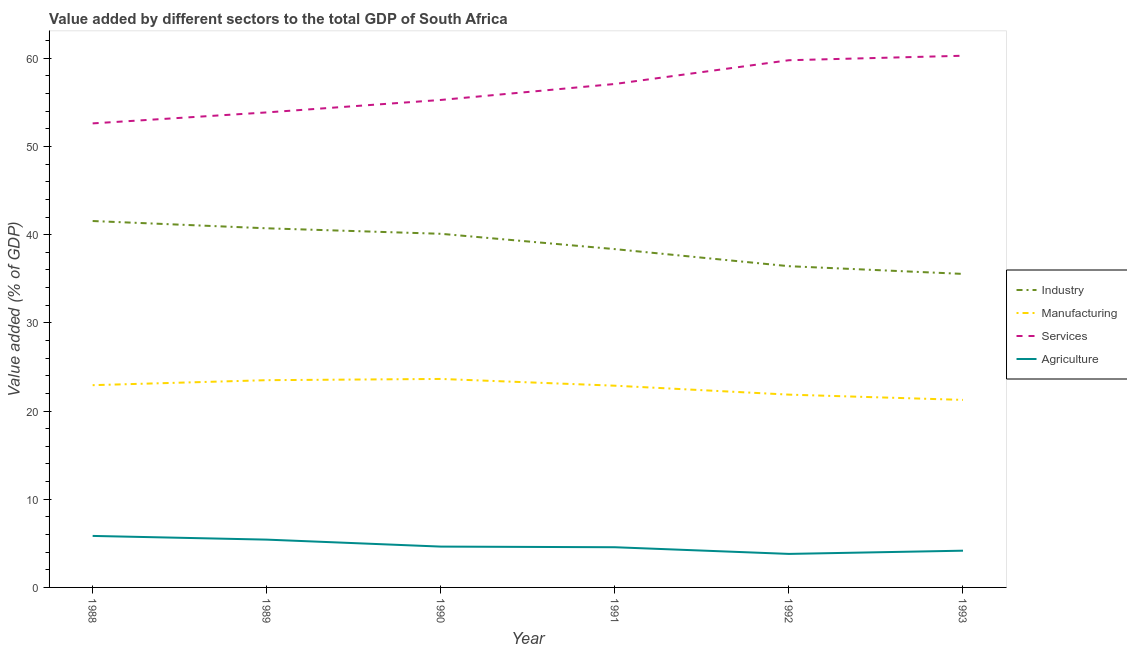Does the line corresponding to value added by industrial sector intersect with the line corresponding to value added by manufacturing sector?
Provide a succinct answer. No. Is the number of lines equal to the number of legend labels?
Give a very brief answer. Yes. What is the value added by services sector in 1990?
Provide a short and direct response. 55.27. Across all years, what is the maximum value added by manufacturing sector?
Keep it short and to the point. 23.64. Across all years, what is the minimum value added by industrial sector?
Offer a terse response. 35.55. What is the total value added by agricultural sector in the graph?
Provide a short and direct response. 28.41. What is the difference between the value added by industrial sector in 1988 and that in 1991?
Keep it short and to the point. 3.19. What is the difference between the value added by manufacturing sector in 1993 and the value added by services sector in 1991?
Your answer should be compact. -35.82. What is the average value added by services sector per year?
Offer a very short reply. 56.48. In the year 1990, what is the difference between the value added by agricultural sector and value added by services sector?
Offer a terse response. -50.64. What is the ratio of the value added by industrial sector in 1992 to that in 1993?
Provide a succinct answer. 1.02. Is the difference between the value added by services sector in 1990 and 1992 greater than the difference between the value added by agricultural sector in 1990 and 1992?
Your response must be concise. No. What is the difference between the highest and the second highest value added by industrial sector?
Keep it short and to the point. 0.83. What is the difference between the highest and the lowest value added by industrial sector?
Offer a very short reply. 6. Is the sum of the value added by agricultural sector in 1989 and 1993 greater than the maximum value added by services sector across all years?
Give a very brief answer. No. Is it the case that in every year, the sum of the value added by agricultural sector and value added by industrial sector is greater than the sum of value added by manufacturing sector and value added by services sector?
Provide a succinct answer. Yes. How many years are there in the graph?
Ensure brevity in your answer.  6. Are the values on the major ticks of Y-axis written in scientific E-notation?
Make the answer very short. No. Does the graph contain any zero values?
Keep it short and to the point. No. Where does the legend appear in the graph?
Ensure brevity in your answer.  Center right. How are the legend labels stacked?
Provide a succinct answer. Vertical. What is the title of the graph?
Give a very brief answer. Value added by different sectors to the total GDP of South Africa. Does "Taxes on goods and services" appear as one of the legend labels in the graph?
Keep it short and to the point. No. What is the label or title of the Y-axis?
Provide a short and direct response. Value added (% of GDP). What is the Value added (% of GDP) in Industry in 1988?
Offer a terse response. 41.55. What is the Value added (% of GDP) of Manufacturing in 1988?
Provide a succinct answer. 22.93. What is the Value added (% of GDP) of Services in 1988?
Make the answer very short. 52.61. What is the Value added (% of GDP) of Agriculture in 1988?
Your answer should be very brief. 5.84. What is the Value added (% of GDP) in Industry in 1989?
Keep it short and to the point. 40.72. What is the Value added (% of GDP) in Manufacturing in 1989?
Provide a succinct answer. 23.5. What is the Value added (% of GDP) of Services in 1989?
Keep it short and to the point. 53.86. What is the Value added (% of GDP) in Agriculture in 1989?
Provide a succinct answer. 5.42. What is the Value added (% of GDP) in Industry in 1990?
Your answer should be very brief. 40.1. What is the Value added (% of GDP) of Manufacturing in 1990?
Your answer should be compact. 23.64. What is the Value added (% of GDP) in Services in 1990?
Give a very brief answer. 55.27. What is the Value added (% of GDP) in Agriculture in 1990?
Ensure brevity in your answer.  4.63. What is the Value added (% of GDP) of Industry in 1991?
Make the answer very short. 38.36. What is the Value added (% of GDP) in Manufacturing in 1991?
Provide a short and direct response. 22.87. What is the Value added (% of GDP) in Services in 1991?
Make the answer very short. 57.08. What is the Value added (% of GDP) in Agriculture in 1991?
Your response must be concise. 4.56. What is the Value added (% of GDP) in Industry in 1992?
Provide a short and direct response. 36.42. What is the Value added (% of GDP) in Manufacturing in 1992?
Your answer should be very brief. 21.86. What is the Value added (% of GDP) in Services in 1992?
Provide a short and direct response. 59.78. What is the Value added (% of GDP) in Agriculture in 1992?
Give a very brief answer. 3.8. What is the Value added (% of GDP) of Industry in 1993?
Your response must be concise. 35.55. What is the Value added (% of GDP) in Manufacturing in 1993?
Your response must be concise. 21.26. What is the Value added (% of GDP) in Services in 1993?
Provide a short and direct response. 60.29. What is the Value added (% of GDP) in Agriculture in 1993?
Provide a succinct answer. 4.17. Across all years, what is the maximum Value added (% of GDP) of Industry?
Offer a very short reply. 41.55. Across all years, what is the maximum Value added (% of GDP) of Manufacturing?
Give a very brief answer. 23.64. Across all years, what is the maximum Value added (% of GDP) of Services?
Give a very brief answer. 60.29. Across all years, what is the maximum Value added (% of GDP) in Agriculture?
Give a very brief answer. 5.84. Across all years, what is the minimum Value added (% of GDP) in Industry?
Your response must be concise. 35.55. Across all years, what is the minimum Value added (% of GDP) in Manufacturing?
Offer a very short reply. 21.26. Across all years, what is the minimum Value added (% of GDP) of Services?
Ensure brevity in your answer.  52.61. Across all years, what is the minimum Value added (% of GDP) in Agriculture?
Ensure brevity in your answer.  3.8. What is the total Value added (% of GDP) in Industry in the graph?
Offer a terse response. 232.69. What is the total Value added (% of GDP) of Manufacturing in the graph?
Offer a very short reply. 136.07. What is the total Value added (% of GDP) of Services in the graph?
Provide a short and direct response. 338.89. What is the total Value added (% of GDP) of Agriculture in the graph?
Give a very brief answer. 28.41. What is the difference between the Value added (% of GDP) in Industry in 1988 and that in 1989?
Your response must be concise. 0.83. What is the difference between the Value added (% of GDP) in Manufacturing in 1988 and that in 1989?
Ensure brevity in your answer.  -0.57. What is the difference between the Value added (% of GDP) in Services in 1988 and that in 1989?
Provide a succinct answer. -1.25. What is the difference between the Value added (% of GDP) of Agriculture in 1988 and that in 1989?
Keep it short and to the point. 0.42. What is the difference between the Value added (% of GDP) of Industry in 1988 and that in 1990?
Your answer should be very brief. 1.45. What is the difference between the Value added (% of GDP) of Manufacturing in 1988 and that in 1990?
Your answer should be compact. -0.71. What is the difference between the Value added (% of GDP) in Services in 1988 and that in 1990?
Ensure brevity in your answer.  -2.66. What is the difference between the Value added (% of GDP) in Agriculture in 1988 and that in 1990?
Your answer should be very brief. 1.21. What is the difference between the Value added (% of GDP) in Industry in 1988 and that in 1991?
Your answer should be compact. 3.19. What is the difference between the Value added (% of GDP) in Manufacturing in 1988 and that in 1991?
Your answer should be compact. 0.06. What is the difference between the Value added (% of GDP) in Services in 1988 and that in 1991?
Provide a short and direct response. -4.47. What is the difference between the Value added (% of GDP) in Agriculture in 1988 and that in 1991?
Provide a short and direct response. 1.28. What is the difference between the Value added (% of GDP) in Industry in 1988 and that in 1992?
Provide a succinct answer. 5.12. What is the difference between the Value added (% of GDP) in Manufacturing in 1988 and that in 1992?
Provide a succinct answer. 1.07. What is the difference between the Value added (% of GDP) of Services in 1988 and that in 1992?
Offer a very short reply. -7.16. What is the difference between the Value added (% of GDP) in Agriculture in 1988 and that in 1992?
Provide a succinct answer. 2.04. What is the difference between the Value added (% of GDP) of Industry in 1988 and that in 1993?
Offer a terse response. 6. What is the difference between the Value added (% of GDP) of Manufacturing in 1988 and that in 1993?
Offer a very short reply. 1.67. What is the difference between the Value added (% of GDP) of Services in 1988 and that in 1993?
Ensure brevity in your answer.  -7.67. What is the difference between the Value added (% of GDP) in Agriculture in 1988 and that in 1993?
Your answer should be compact. 1.67. What is the difference between the Value added (% of GDP) of Industry in 1989 and that in 1990?
Ensure brevity in your answer.  0.62. What is the difference between the Value added (% of GDP) in Manufacturing in 1989 and that in 1990?
Make the answer very short. -0.14. What is the difference between the Value added (% of GDP) of Services in 1989 and that in 1990?
Your answer should be compact. -1.41. What is the difference between the Value added (% of GDP) of Agriculture in 1989 and that in 1990?
Offer a very short reply. 0.79. What is the difference between the Value added (% of GDP) of Industry in 1989 and that in 1991?
Offer a very short reply. 2.36. What is the difference between the Value added (% of GDP) in Manufacturing in 1989 and that in 1991?
Offer a very short reply. 0.63. What is the difference between the Value added (% of GDP) in Services in 1989 and that in 1991?
Your answer should be compact. -3.22. What is the difference between the Value added (% of GDP) of Agriculture in 1989 and that in 1991?
Make the answer very short. 0.86. What is the difference between the Value added (% of GDP) of Industry in 1989 and that in 1992?
Provide a short and direct response. 4.3. What is the difference between the Value added (% of GDP) in Manufacturing in 1989 and that in 1992?
Your response must be concise. 1.64. What is the difference between the Value added (% of GDP) in Services in 1989 and that in 1992?
Your answer should be compact. -5.92. What is the difference between the Value added (% of GDP) in Agriculture in 1989 and that in 1992?
Offer a terse response. 1.62. What is the difference between the Value added (% of GDP) of Industry in 1989 and that in 1993?
Your answer should be compact. 5.17. What is the difference between the Value added (% of GDP) of Manufacturing in 1989 and that in 1993?
Your answer should be very brief. 2.24. What is the difference between the Value added (% of GDP) of Services in 1989 and that in 1993?
Your answer should be very brief. -6.43. What is the difference between the Value added (% of GDP) in Agriculture in 1989 and that in 1993?
Offer a very short reply. 1.25. What is the difference between the Value added (% of GDP) of Industry in 1990 and that in 1991?
Give a very brief answer. 1.74. What is the difference between the Value added (% of GDP) of Manufacturing in 1990 and that in 1991?
Offer a terse response. 0.77. What is the difference between the Value added (% of GDP) of Services in 1990 and that in 1991?
Your answer should be compact. -1.81. What is the difference between the Value added (% of GDP) in Agriculture in 1990 and that in 1991?
Ensure brevity in your answer.  0.07. What is the difference between the Value added (% of GDP) of Industry in 1990 and that in 1992?
Offer a terse response. 3.67. What is the difference between the Value added (% of GDP) in Manufacturing in 1990 and that in 1992?
Provide a short and direct response. 1.78. What is the difference between the Value added (% of GDP) of Services in 1990 and that in 1992?
Give a very brief answer. -4.5. What is the difference between the Value added (% of GDP) in Agriculture in 1990 and that in 1992?
Provide a succinct answer. 0.83. What is the difference between the Value added (% of GDP) of Industry in 1990 and that in 1993?
Your answer should be very brief. 4.55. What is the difference between the Value added (% of GDP) in Manufacturing in 1990 and that in 1993?
Give a very brief answer. 2.38. What is the difference between the Value added (% of GDP) of Services in 1990 and that in 1993?
Your response must be concise. -5.01. What is the difference between the Value added (% of GDP) of Agriculture in 1990 and that in 1993?
Offer a terse response. 0.46. What is the difference between the Value added (% of GDP) in Industry in 1991 and that in 1992?
Provide a short and direct response. 1.94. What is the difference between the Value added (% of GDP) of Manufacturing in 1991 and that in 1992?
Your answer should be compact. 1.01. What is the difference between the Value added (% of GDP) of Services in 1991 and that in 1992?
Offer a terse response. -2.69. What is the difference between the Value added (% of GDP) of Agriculture in 1991 and that in 1992?
Offer a very short reply. 0.76. What is the difference between the Value added (% of GDP) of Industry in 1991 and that in 1993?
Your response must be concise. 2.81. What is the difference between the Value added (% of GDP) of Manufacturing in 1991 and that in 1993?
Offer a terse response. 1.61. What is the difference between the Value added (% of GDP) of Services in 1991 and that in 1993?
Provide a succinct answer. -3.2. What is the difference between the Value added (% of GDP) of Agriculture in 1991 and that in 1993?
Your answer should be very brief. 0.39. What is the difference between the Value added (% of GDP) of Industry in 1992 and that in 1993?
Make the answer very short. 0.88. What is the difference between the Value added (% of GDP) in Manufacturing in 1992 and that in 1993?
Provide a succinct answer. 0.6. What is the difference between the Value added (% of GDP) in Services in 1992 and that in 1993?
Give a very brief answer. -0.51. What is the difference between the Value added (% of GDP) of Agriculture in 1992 and that in 1993?
Ensure brevity in your answer.  -0.37. What is the difference between the Value added (% of GDP) of Industry in 1988 and the Value added (% of GDP) of Manufacturing in 1989?
Your answer should be very brief. 18.05. What is the difference between the Value added (% of GDP) in Industry in 1988 and the Value added (% of GDP) in Services in 1989?
Your answer should be compact. -12.31. What is the difference between the Value added (% of GDP) in Industry in 1988 and the Value added (% of GDP) in Agriculture in 1989?
Your answer should be very brief. 36.13. What is the difference between the Value added (% of GDP) in Manufacturing in 1988 and the Value added (% of GDP) in Services in 1989?
Provide a succinct answer. -30.93. What is the difference between the Value added (% of GDP) of Manufacturing in 1988 and the Value added (% of GDP) of Agriculture in 1989?
Make the answer very short. 17.51. What is the difference between the Value added (% of GDP) of Services in 1988 and the Value added (% of GDP) of Agriculture in 1989?
Ensure brevity in your answer.  47.2. What is the difference between the Value added (% of GDP) of Industry in 1988 and the Value added (% of GDP) of Manufacturing in 1990?
Keep it short and to the point. 17.91. What is the difference between the Value added (% of GDP) in Industry in 1988 and the Value added (% of GDP) in Services in 1990?
Your answer should be compact. -13.73. What is the difference between the Value added (% of GDP) in Industry in 1988 and the Value added (% of GDP) in Agriculture in 1990?
Offer a terse response. 36.92. What is the difference between the Value added (% of GDP) of Manufacturing in 1988 and the Value added (% of GDP) of Services in 1990?
Give a very brief answer. -32.34. What is the difference between the Value added (% of GDP) of Manufacturing in 1988 and the Value added (% of GDP) of Agriculture in 1990?
Offer a terse response. 18.3. What is the difference between the Value added (% of GDP) of Services in 1988 and the Value added (% of GDP) of Agriculture in 1990?
Provide a succinct answer. 47.98. What is the difference between the Value added (% of GDP) in Industry in 1988 and the Value added (% of GDP) in Manufacturing in 1991?
Make the answer very short. 18.67. What is the difference between the Value added (% of GDP) in Industry in 1988 and the Value added (% of GDP) in Services in 1991?
Offer a very short reply. -15.54. What is the difference between the Value added (% of GDP) of Industry in 1988 and the Value added (% of GDP) of Agriculture in 1991?
Make the answer very short. 36.99. What is the difference between the Value added (% of GDP) in Manufacturing in 1988 and the Value added (% of GDP) in Services in 1991?
Your answer should be compact. -34.15. What is the difference between the Value added (% of GDP) of Manufacturing in 1988 and the Value added (% of GDP) of Agriculture in 1991?
Provide a short and direct response. 18.38. What is the difference between the Value added (% of GDP) in Services in 1988 and the Value added (% of GDP) in Agriculture in 1991?
Make the answer very short. 48.06. What is the difference between the Value added (% of GDP) in Industry in 1988 and the Value added (% of GDP) in Manufacturing in 1992?
Your response must be concise. 19.69. What is the difference between the Value added (% of GDP) in Industry in 1988 and the Value added (% of GDP) in Services in 1992?
Offer a very short reply. -18.23. What is the difference between the Value added (% of GDP) in Industry in 1988 and the Value added (% of GDP) in Agriculture in 1992?
Your answer should be very brief. 37.75. What is the difference between the Value added (% of GDP) in Manufacturing in 1988 and the Value added (% of GDP) in Services in 1992?
Your response must be concise. -36.84. What is the difference between the Value added (% of GDP) of Manufacturing in 1988 and the Value added (% of GDP) of Agriculture in 1992?
Provide a short and direct response. 19.13. What is the difference between the Value added (% of GDP) of Services in 1988 and the Value added (% of GDP) of Agriculture in 1992?
Your answer should be compact. 48.81. What is the difference between the Value added (% of GDP) in Industry in 1988 and the Value added (% of GDP) in Manufacturing in 1993?
Provide a short and direct response. 20.28. What is the difference between the Value added (% of GDP) of Industry in 1988 and the Value added (% of GDP) of Services in 1993?
Your answer should be very brief. -18.74. What is the difference between the Value added (% of GDP) in Industry in 1988 and the Value added (% of GDP) in Agriculture in 1993?
Offer a very short reply. 37.38. What is the difference between the Value added (% of GDP) of Manufacturing in 1988 and the Value added (% of GDP) of Services in 1993?
Your answer should be compact. -37.35. What is the difference between the Value added (% of GDP) in Manufacturing in 1988 and the Value added (% of GDP) in Agriculture in 1993?
Provide a succinct answer. 18.77. What is the difference between the Value added (% of GDP) in Services in 1988 and the Value added (% of GDP) in Agriculture in 1993?
Provide a succinct answer. 48.45. What is the difference between the Value added (% of GDP) in Industry in 1989 and the Value added (% of GDP) in Manufacturing in 1990?
Your response must be concise. 17.08. What is the difference between the Value added (% of GDP) in Industry in 1989 and the Value added (% of GDP) in Services in 1990?
Ensure brevity in your answer.  -14.55. What is the difference between the Value added (% of GDP) of Industry in 1989 and the Value added (% of GDP) of Agriculture in 1990?
Give a very brief answer. 36.09. What is the difference between the Value added (% of GDP) in Manufacturing in 1989 and the Value added (% of GDP) in Services in 1990?
Provide a succinct answer. -31.77. What is the difference between the Value added (% of GDP) in Manufacturing in 1989 and the Value added (% of GDP) in Agriculture in 1990?
Offer a very short reply. 18.87. What is the difference between the Value added (% of GDP) in Services in 1989 and the Value added (% of GDP) in Agriculture in 1990?
Give a very brief answer. 49.23. What is the difference between the Value added (% of GDP) of Industry in 1989 and the Value added (% of GDP) of Manufacturing in 1991?
Provide a short and direct response. 17.85. What is the difference between the Value added (% of GDP) in Industry in 1989 and the Value added (% of GDP) in Services in 1991?
Give a very brief answer. -16.36. What is the difference between the Value added (% of GDP) of Industry in 1989 and the Value added (% of GDP) of Agriculture in 1991?
Your response must be concise. 36.16. What is the difference between the Value added (% of GDP) in Manufacturing in 1989 and the Value added (% of GDP) in Services in 1991?
Your response must be concise. -33.59. What is the difference between the Value added (% of GDP) in Manufacturing in 1989 and the Value added (% of GDP) in Agriculture in 1991?
Make the answer very short. 18.94. What is the difference between the Value added (% of GDP) in Services in 1989 and the Value added (% of GDP) in Agriculture in 1991?
Give a very brief answer. 49.3. What is the difference between the Value added (% of GDP) of Industry in 1989 and the Value added (% of GDP) of Manufacturing in 1992?
Your answer should be very brief. 18.86. What is the difference between the Value added (% of GDP) of Industry in 1989 and the Value added (% of GDP) of Services in 1992?
Give a very brief answer. -19.06. What is the difference between the Value added (% of GDP) in Industry in 1989 and the Value added (% of GDP) in Agriculture in 1992?
Your answer should be very brief. 36.92. What is the difference between the Value added (% of GDP) in Manufacturing in 1989 and the Value added (% of GDP) in Services in 1992?
Keep it short and to the point. -36.28. What is the difference between the Value added (% of GDP) in Manufacturing in 1989 and the Value added (% of GDP) in Agriculture in 1992?
Keep it short and to the point. 19.7. What is the difference between the Value added (% of GDP) in Services in 1989 and the Value added (% of GDP) in Agriculture in 1992?
Ensure brevity in your answer.  50.06. What is the difference between the Value added (% of GDP) of Industry in 1989 and the Value added (% of GDP) of Manufacturing in 1993?
Your answer should be very brief. 19.46. What is the difference between the Value added (% of GDP) of Industry in 1989 and the Value added (% of GDP) of Services in 1993?
Ensure brevity in your answer.  -19.57. What is the difference between the Value added (% of GDP) in Industry in 1989 and the Value added (% of GDP) in Agriculture in 1993?
Keep it short and to the point. 36.55. What is the difference between the Value added (% of GDP) in Manufacturing in 1989 and the Value added (% of GDP) in Services in 1993?
Provide a short and direct response. -36.79. What is the difference between the Value added (% of GDP) in Manufacturing in 1989 and the Value added (% of GDP) in Agriculture in 1993?
Give a very brief answer. 19.33. What is the difference between the Value added (% of GDP) of Services in 1989 and the Value added (% of GDP) of Agriculture in 1993?
Give a very brief answer. 49.69. What is the difference between the Value added (% of GDP) in Industry in 1990 and the Value added (% of GDP) in Manufacturing in 1991?
Offer a terse response. 17.22. What is the difference between the Value added (% of GDP) of Industry in 1990 and the Value added (% of GDP) of Services in 1991?
Provide a succinct answer. -16.99. What is the difference between the Value added (% of GDP) of Industry in 1990 and the Value added (% of GDP) of Agriculture in 1991?
Your response must be concise. 35.54. What is the difference between the Value added (% of GDP) in Manufacturing in 1990 and the Value added (% of GDP) in Services in 1991?
Make the answer very short. -33.44. What is the difference between the Value added (% of GDP) in Manufacturing in 1990 and the Value added (% of GDP) in Agriculture in 1991?
Ensure brevity in your answer.  19.08. What is the difference between the Value added (% of GDP) of Services in 1990 and the Value added (% of GDP) of Agriculture in 1991?
Give a very brief answer. 50.72. What is the difference between the Value added (% of GDP) of Industry in 1990 and the Value added (% of GDP) of Manufacturing in 1992?
Provide a succinct answer. 18.24. What is the difference between the Value added (% of GDP) in Industry in 1990 and the Value added (% of GDP) in Services in 1992?
Offer a terse response. -19.68. What is the difference between the Value added (% of GDP) of Industry in 1990 and the Value added (% of GDP) of Agriculture in 1992?
Your answer should be compact. 36.3. What is the difference between the Value added (% of GDP) of Manufacturing in 1990 and the Value added (% of GDP) of Services in 1992?
Your answer should be compact. -36.14. What is the difference between the Value added (% of GDP) in Manufacturing in 1990 and the Value added (% of GDP) in Agriculture in 1992?
Make the answer very short. 19.84. What is the difference between the Value added (% of GDP) of Services in 1990 and the Value added (% of GDP) of Agriculture in 1992?
Provide a short and direct response. 51.47. What is the difference between the Value added (% of GDP) of Industry in 1990 and the Value added (% of GDP) of Manufacturing in 1993?
Provide a succinct answer. 18.83. What is the difference between the Value added (% of GDP) of Industry in 1990 and the Value added (% of GDP) of Services in 1993?
Offer a terse response. -20.19. What is the difference between the Value added (% of GDP) of Industry in 1990 and the Value added (% of GDP) of Agriculture in 1993?
Make the answer very short. 35.93. What is the difference between the Value added (% of GDP) in Manufacturing in 1990 and the Value added (% of GDP) in Services in 1993?
Offer a terse response. -36.65. What is the difference between the Value added (% of GDP) of Manufacturing in 1990 and the Value added (% of GDP) of Agriculture in 1993?
Provide a short and direct response. 19.47. What is the difference between the Value added (% of GDP) of Services in 1990 and the Value added (% of GDP) of Agriculture in 1993?
Give a very brief answer. 51.11. What is the difference between the Value added (% of GDP) of Industry in 1991 and the Value added (% of GDP) of Manufacturing in 1992?
Offer a terse response. 16.5. What is the difference between the Value added (% of GDP) in Industry in 1991 and the Value added (% of GDP) in Services in 1992?
Provide a short and direct response. -21.42. What is the difference between the Value added (% of GDP) in Industry in 1991 and the Value added (% of GDP) in Agriculture in 1992?
Your response must be concise. 34.56. What is the difference between the Value added (% of GDP) in Manufacturing in 1991 and the Value added (% of GDP) in Services in 1992?
Your answer should be compact. -36.9. What is the difference between the Value added (% of GDP) in Manufacturing in 1991 and the Value added (% of GDP) in Agriculture in 1992?
Keep it short and to the point. 19.07. What is the difference between the Value added (% of GDP) of Services in 1991 and the Value added (% of GDP) of Agriculture in 1992?
Your answer should be compact. 53.28. What is the difference between the Value added (% of GDP) of Industry in 1991 and the Value added (% of GDP) of Manufacturing in 1993?
Make the answer very short. 17.1. What is the difference between the Value added (% of GDP) of Industry in 1991 and the Value added (% of GDP) of Services in 1993?
Your answer should be very brief. -21.93. What is the difference between the Value added (% of GDP) of Industry in 1991 and the Value added (% of GDP) of Agriculture in 1993?
Make the answer very short. 34.19. What is the difference between the Value added (% of GDP) in Manufacturing in 1991 and the Value added (% of GDP) in Services in 1993?
Provide a short and direct response. -37.41. What is the difference between the Value added (% of GDP) in Manufacturing in 1991 and the Value added (% of GDP) in Agriculture in 1993?
Provide a short and direct response. 18.71. What is the difference between the Value added (% of GDP) in Services in 1991 and the Value added (% of GDP) in Agriculture in 1993?
Your answer should be very brief. 52.92. What is the difference between the Value added (% of GDP) in Industry in 1992 and the Value added (% of GDP) in Manufacturing in 1993?
Keep it short and to the point. 15.16. What is the difference between the Value added (% of GDP) of Industry in 1992 and the Value added (% of GDP) of Services in 1993?
Your answer should be very brief. -23.86. What is the difference between the Value added (% of GDP) of Industry in 1992 and the Value added (% of GDP) of Agriculture in 1993?
Your answer should be very brief. 32.26. What is the difference between the Value added (% of GDP) of Manufacturing in 1992 and the Value added (% of GDP) of Services in 1993?
Give a very brief answer. -38.43. What is the difference between the Value added (% of GDP) of Manufacturing in 1992 and the Value added (% of GDP) of Agriculture in 1993?
Ensure brevity in your answer.  17.69. What is the difference between the Value added (% of GDP) in Services in 1992 and the Value added (% of GDP) in Agriculture in 1993?
Give a very brief answer. 55.61. What is the average Value added (% of GDP) in Industry per year?
Provide a short and direct response. 38.78. What is the average Value added (% of GDP) of Manufacturing per year?
Your answer should be very brief. 22.68. What is the average Value added (% of GDP) of Services per year?
Your answer should be compact. 56.48. What is the average Value added (% of GDP) of Agriculture per year?
Offer a very short reply. 4.74. In the year 1988, what is the difference between the Value added (% of GDP) of Industry and Value added (% of GDP) of Manufacturing?
Provide a succinct answer. 18.61. In the year 1988, what is the difference between the Value added (% of GDP) in Industry and Value added (% of GDP) in Services?
Provide a short and direct response. -11.07. In the year 1988, what is the difference between the Value added (% of GDP) of Industry and Value added (% of GDP) of Agriculture?
Your answer should be compact. 35.71. In the year 1988, what is the difference between the Value added (% of GDP) in Manufacturing and Value added (% of GDP) in Services?
Ensure brevity in your answer.  -29.68. In the year 1988, what is the difference between the Value added (% of GDP) in Manufacturing and Value added (% of GDP) in Agriculture?
Make the answer very short. 17.09. In the year 1988, what is the difference between the Value added (% of GDP) of Services and Value added (% of GDP) of Agriculture?
Ensure brevity in your answer.  46.78. In the year 1989, what is the difference between the Value added (% of GDP) in Industry and Value added (% of GDP) in Manufacturing?
Your answer should be very brief. 17.22. In the year 1989, what is the difference between the Value added (% of GDP) of Industry and Value added (% of GDP) of Services?
Give a very brief answer. -13.14. In the year 1989, what is the difference between the Value added (% of GDP) of Industry and Value added (% of GDP) of Agriculture?
Keep it short and to the point. 35.3. In the year 1989, what is the difference between the Value added (% of GDP) of Manufacturing and Value added (% of GDP) of Services?
Offer a very short reply. -30.36. In the year 1989, what is the difference between the Value added (% of GDP) in Manufacturing and Value added (% of GDP) in Agriculture?
Your answer should be very brief. 18.08. In the year 1989, what is the difference between the Value added (% of GDP) in Services and Value added (% of GDP) in Agriculture?
Provide a short and direct response. 48.44. In the year 1990, what is the difference between the Value added (% of GDP) in Industry and Value added (% of GDP) in Manufacturing?
Provide a short and direct response. 16.46. In the year 1990, what is the difference between the Value added (% of GDP) in Industry and Value added (% of GDP) in Services?
Provide a short and direct response. -15.18. In the year 1990, what is the difference between the Value added (% of GDP) in Industry and Value added (% of GDP) in Agriculture?
Provide a succinct answer. 35.47. In the year 1990, what is the difference between the Value added (% of GDP) of Manufacturing and Value added (% of GDP) of Services?
Your answer should be compact. -31.63. In the year 1990, what is the difference between the Value added (% of GDP) in Manufacturing and Value added (% of GDP) in Agriculture?
Your response must be concise. 19.01. In the year 1990, what is the difference between the Value added (% of GDP) in Services and Value added (% of GDP) in Agriculture?
Offer a terse response. 50.64. In the year 1991, what is the difference between the Value added (% of GDP) in Industry and Value added (% of GDP) in Manufacturing?
Your answer should be compact. 15.49. In the year 1991, what is the difference between the Value added (% of GDP) of Industry and Value added (% of GDP) of Services?
Offer a terse response. -18.72. In the year 1991, what is the difference between the Value added (% of GDP) of Industry and Value added (% of GDP) of Agriculture?
Keep it short and to the point. 33.8. In the year 1991, what is the difference between the Value added (% of GDP) in Manufacturing and Value added (% of GDP) in Services?
Offer a terse response. -34.21. In the year 1991, what is the difference between the Value added (% of GDP) in Manufacturing and Value added (% of GDP) in Agriculture?
Offer a very short reply. 18.32. In the year 1991, what is the difference between the Value added (% of GDP) of Services and Value added (% of GDP) of Agriculture?
Provide a short and direct response. 52.53. In the year 1992, what is the difference between the Value added (% of GDP) in Industry and Value added (% of GDP) in Manufacturing?
Your answer should be compact. 14.56. In the year 1992, what is the difference between the Value added (% of GDP) of Industry and Value added (% of GDP) of Services?
Offer a very short reply. -23.35. In the year 1992, what is the difference between the Value added (% of GDP) in Industry and Value added (% of GDP) in Agriculture?
Ensure brevity in your answer.  32.62. In the year 1992, what is the difference between the Value added (% of GDP) in Manufacturing and Value added (% of GDP) in Services?
Your answer should be very brief. -37.92. In the year 1992, what is the difference between the Value added (% of GDP) of Manufacturing and Value added (% of GDP) of Agriculture?
Keep it short and to the point. 18.06. In the year 1992, what is the difference between the Value added (% of GDP) in Services and Value added (% of GDP) in Agriculture?
Provide a short and direct response. 55.98. In the year 1993, what is the difference between the Value added (% of GDP) of Industry and Value added (% of GDP) of Manufacturing?
Keep it short and to the point. 14.29. In the year 1993, what is the difference between the Value added (% of GDP) of Industry and Value added (% of GDP) of Services?
Offer a very short reply. -24.74. In the year 1993, what is the difference between the Value added (% of GDP) in Industry and Value added (% of GDP) in Agriculture?
Your response must be concise. 31.38. In the year 1993, what is the difference between the Value added (% of GDP) in Manufacturing and Value added (% of GDP) in Services?
Provide a short and direct response. -39.02. In the year 1993, what is the difference between the Value added (% of GDP) in Manufacturing and Value added (% of GDP) in Agriculture?
Your answer should be very brief. 17.1. In the year 1993, what is the difference between the Value added (% of GDP) in Services and Value added (% of GDP) in Agriculture?
Your answer should be very brief. 56.12. What is the ratio of the Value added (% of GDP) in Industry in 1988 to that in 1989?
Provide a succinct answer. 1.02. What is the ratio of the Value added (% of GDP) in Manufacturing in 1988 to that in 1989?
Offer a very short reply. 0.98. What is the ratio of the Value added (% of GDP) of Services in 1988 to that in 1989?
Make the answer very short. 0.98. What is the ratio of the Value added (% of GDP) in Agriculture in 1988 to that in 1989?
Make the answer very short. 1.08. What is the ratio of the Value added (% of GDP) in Industry in 1988 to that in 1990?
Your answer should be very brief. 1.04. What is the ratio of the Value added (% of GDP) in Manufacturing in 1988 to that in 1990?
Your answer should be very brief. 0.97. What is the ratio of the Value added (% of GDP) of Services in 1988 to that in 1990?
Your answer should be very brief. 0.95. What is the ratio of the Value added (% of GDP) in Agriculture in 1988 to that in 1990?
Offer a very short reply. 1.26. What is the ratio of the Value added (% of GDP) of Industry in 1988 to that in 1991?
Offer a very short reply. 1.08. What is the ratio of the Value added (% of GDP) in Manufacturing in 1988 to that in 1991?
Your answer should be compact. 1. What is the ratio of the Value added (% of GDP) in Services in 1988 to that in 1991?
Keep it short and to the point. 0.92. What is the ratio of the Value added (% of GDP) of Agriculture in 1988 to that in 1991?
Ensure brevity in your answer.  1.28. What is the ratio of the Value added (% of GDP) in Industry in 1988 to that in 1992?
Your answer should be very brief. 1.14. What is the ratio of the Value added (% of GDP) of Manufacturing in 1988 to that in 1992?
Offer a terse response. 1.05. What is the ratio of the Value added (% of GDP) of Services in 1988 to that in 1992?
Your answer should be compact. 0.88. What is the ratio of the Value added (% of GDP) in Agriculture in 1988 to that in 1992?
Provide a succinct answer. 1.54. What is the ratio of the Value added (% of GDP) of Industry in 1988 to that in 1993?
Ensure brevity in your answer.  1.17. What is the ratio of the Value added (% of GDP) in Manufacturing in 1988 to that in 1993?
Offer a terse response. 1.08. What is the ratio of the Value added (% of GDP) in Services in 1988 to that in 1993?
Provide a short and direct response. 0.87. What is the ratio of the Value added (% of GDP) of Agriculture in 1988 to that in 1993?
Keep it short and to the point. 1.4. What is the ratio of the Value added (% of GDP) of Industry in 1989 to that in 1990?
Ensure brevity in your answer.  1.02. What is the ratio of the Value added (% of GDP) of Manufacturing in 1989 to that in 1990?
Ensure brevity in your answer.  0.99. What is the ratio of the Value added (% of GDP) in Services in 1989 to that in 1990?
Your answer should be very brief. 0.97. What is the ratio of the Value added (% of GDP) of Agriculture in 1989 to that in 1990?
Give a very brief answer. 1.17. What is the ratio of the Value added (% of GDP) of Industry in 1989 to that in 1991?
Offer a very short reply. 1.06. What is the ratio of the Value added (% of GDP) of Manufacturing in 1989 to that in 1991?
Provide a short and direct response. 1.03. What is the ratio of the Value added (% of GDP) in Services in 1989 to that in 1991?
Ensure brevity in your answer.  0.94. What is the ratio of the Value added (% of GDP) of Agriculture in 1989 to that in 1991?
Your answer should be very brief. 1.19. What is the ratio of the Value added (% of GDP) of Industry in 1989 to that in 1992?
Give a very brief answer. 1.12. What is the ratio of the Value added (% of GDP) of Manufacturing in 1989 to that in 1992?
Provide a succinct answer. 1.07. What is the ratio of the Value added (% of GDP) of Services in 1989 to that in 1992?
Make the answer very short. 0.9. What is the ratio of the Value added (% of GDP) in Agriculture in 1989 to that in 1992?
Your answer should be very brief. 1.43. What is the ratio of the Value added (% of GDP) of Industry in 1989 to that in 1993?
Offer a very short reply. 1.15. What is the ratio of the Value added (% of GDP) in Manufacturing in 1989 to that in 1993?
Ensure brevity in your answer.  1.11. What is the ratio of the Value added (% of GDP) of Services in 1989 to that in 1993?
Your answer should be very brief. 0.89. What is the ratio of the Value added (% of GDP) of Agriculture in 1989 to that in 1993?
Provide a succinct answer. 1.3. What is the ratio of the Value added (% of GDP) in Industry in 1990 to that in 1991?
Make the answer very short. 1.05. What is the ratio of the Value added (% of GDP) in Manufacturing in 1990 to that in 1991?
Give a very brief answer. 1.03. What is the ratio of the Value added (% of GDP) of Services in 1990 to that in 1991?
Provide a short and direct response. 0.97. What is the ratio of the Value added (% of GDP) of Agriculture in 1990 to that in 1991?
Provide a succinct answer. 1.02. What is the ratio of the Value added (% of GDP) in Industry in 1990 to that in 1992?
Give a very brief answer. 1.1. What is the ratio of the Value added (% of GDP) in Manufacturing in 1990 to that in 1992?
Keep it short and to the point. 1.08. What is the ratio of the Value added (% of GDP) of Services in 1990 to that in 1992?
Make the answer very short. 0.92. What is the ratio of the Value added (% of GDP) of Agriculture in 1990 to that in 1992?
Provide a succinct answer. 1.22. What is the ratio of the Value added (% of GDP) of Industry in 1990 to that in 1993?
Ensure brevity in your answer.  1.13. What is the ratio of the Value added (% of GDP) of Manufacturing in 1990 to that in 1993?
Offer a terse response. 1.11. What is the ratio of the Value added (% of GDP) of Services in 1990 to that in 1993?
Offer a very short reply. 0.92. What is the ratio of the Value added (% of GDP) of Agriculture in 1990 to that in 1993?
Keep it short and to the point. 1.11. What is the ratio of the Value added (% of GDP) of Industry in 1991 to that in 1992?
Your answer should be very brief. 1.05. What is the ratio of the Value added (% of GDP) in Manufacturing in 1991 to that in 1992?
Ensure brevity in your answer.  1.05. What is the ratio of the Value added (% of GDP) of Services in 1991 to that in 1992?
Offer a very short reply. 0.95. What is the ratio of the Value added (% of GDP) of Agriculture in 1991 to that in 1992?
Your response must be concise. 1.2. What is the ratio of the Value added (% of GDP) in Industry in 1991 to that in 1993?
Give a very brief answer. 1.08. What is the ratio of the Value added (% of GDP) in Manufacturing in 1991 to that in 1993?
Ensure brevity in your answer.  1.08. What is the ratio of the Value added (% of GDP) of Services in 1991 to that in 1993?
Provide a short and direct response. 0.95. What is the ratio of the Value added (% of GDP) of Agriculture in 1991 to that in 1993?
Make the answer very short. 1.09. What is the ratio of the Value added (% of GDP) in Industry in 1992 to that in 1993?
Give a very brief answer. 1.02. What is the ratio of the Value added (% of GDP) in Manufacturing in 1992 to that in 1993?
Provide a short and direct response. 1.03. What is the ratio of the Value added (% of GDP) of Agriculture in 1992 to that in 1993?
Offer a very short reply. 0.91. What is the difference between the highest and the second highest Value added (% of GDP) of Industry?
Your answer should be compact. 0.83. What is the difference between the highest and the second highest Value added (% of GDP) in Manufacturing?
Provide a short and direct response. 0.14. What is the difference between the highest and the second highest Value added (% of GDP) of Services?
Give a very brief answer. 0.51. What is the difference between the highest and the second highest Value added (% of GDP) of Agriculture?
Your answer should be very brief. 0.42. What is the difference between the highest and the lowest Value added (% of GDP) in Industry?
Provide a succinct answer. 6. What is the difference between the highest and the lowest Value added (% of GDP) in Manufacturing?
Provide a short and direct response. 2.38. What is the difference between the highest and the lowest Value added (% of GDP) in Services?
Give a very brief answer. 7.67. What is the difference between the highest and the lowest Value added (% of GDP) in Agriculture?
Ensure brevity in your answer.  2.04. 